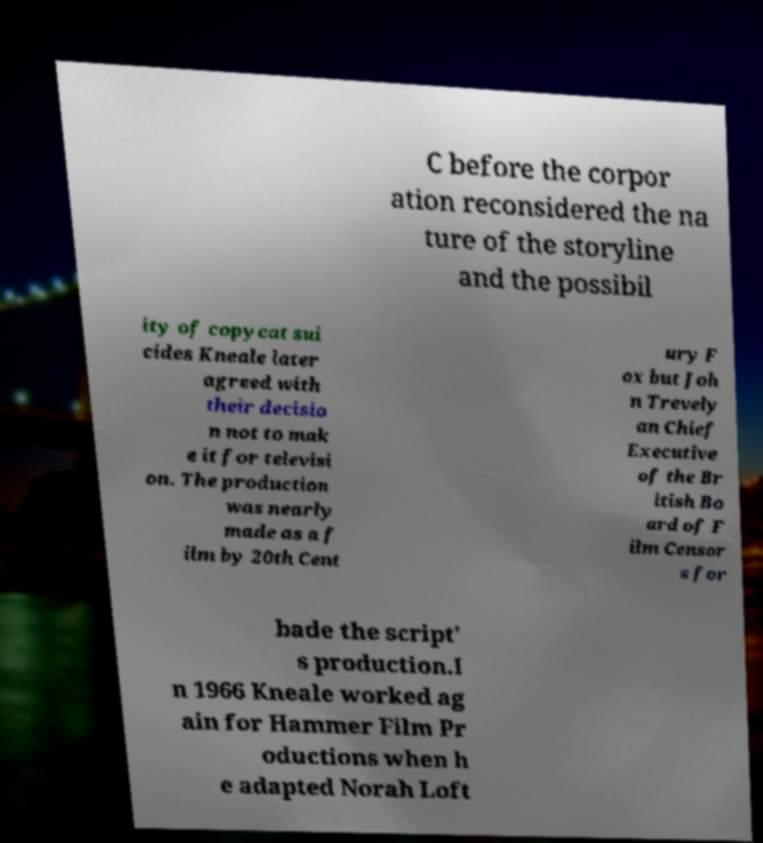What messages or text are displayed in this image? I need them in a readable, typed format. C before the corpor ation reconsidered the na ture of the storyline and the possibil ity of copycat sui cides Kneale later agreed with their decisio n not to mak e it for televisi on. The production was nearly made as a f ilm by 20th Cent ury F ox but Joh n Trevely an Chief Executive of the Br itish Bo ard of F ilm Censor s for bade the script' s production.I n 1966 Kneale worked ag ain for Hammer Film Pr oductions when h e adapted Norah Loft 